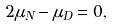Convert formula to latex. <formula><loc_0><loc_0><loc_500><loc_500>2 \mu _ { N } - \mu _ { D } = 0 ,</formula> 